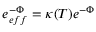<formula> <loc_0><loc_0><loc_500><loc_500>e _ { e f f } ^ { - \Phi } = \kappa ( T ) e ^ { - \Phi }</formula> 